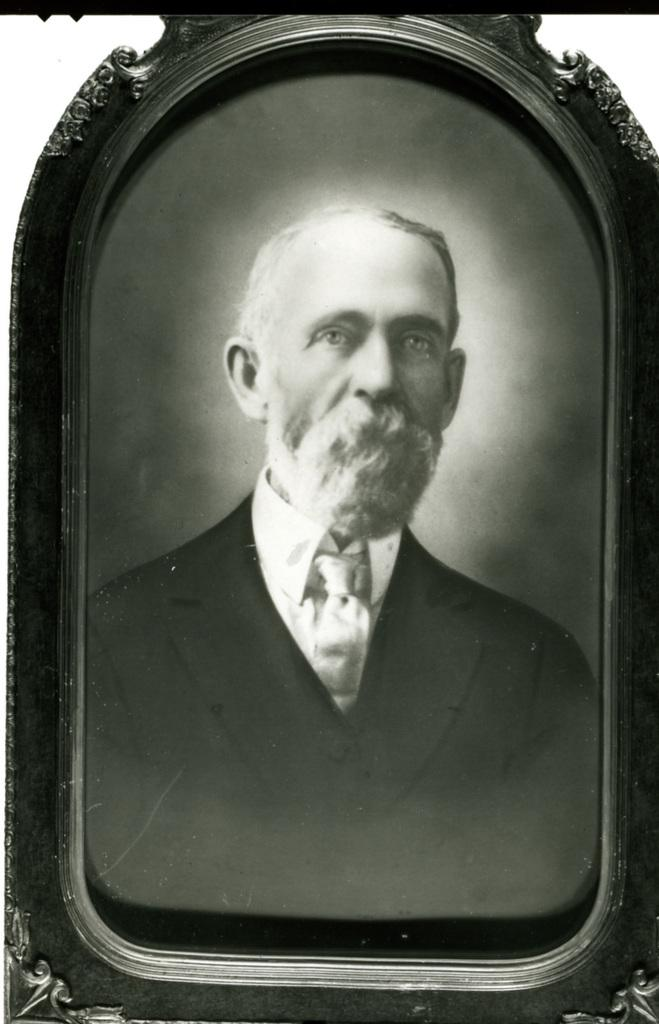What is the color scheme of the image? The image is black and white. What object is present in the image? There is a photo frame in the image. What can be seen inside the photo frame? The photo frame contains a photo of a man. How many ants are crawling on the bread in the image? There is no bread or ants present in the image; it features a photo frame with a photo of a man. 